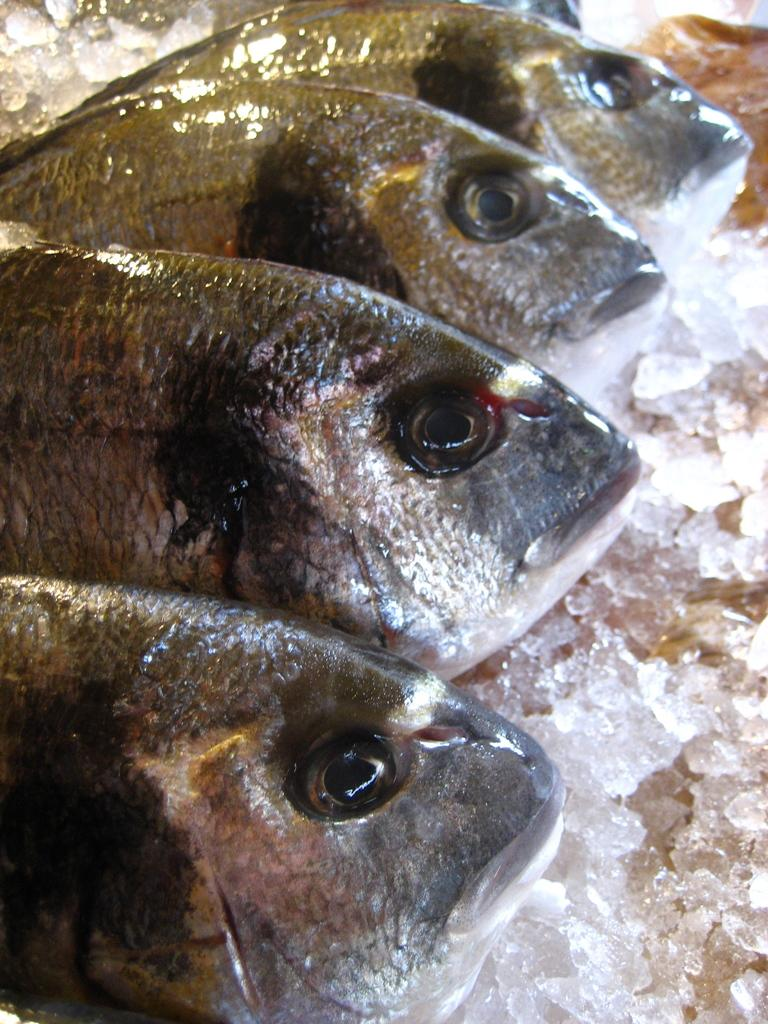How many fishes can be seen in the image? There are four fishes in the image. How are the fishes arranged? The fishes are arranged in a line. What is present at the bottom of the image? There is ice at the bottom of the image. What type of yard can be seen in the image? There is no yard present in the image; it features four fishes arranged in a line with ice at the bottom. 